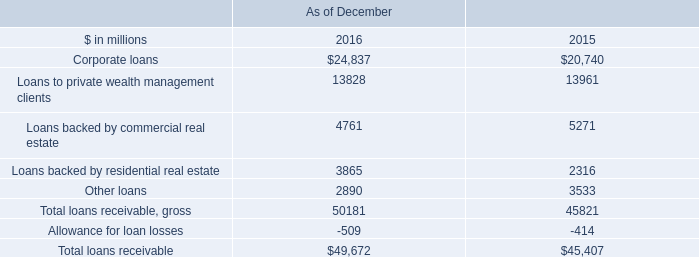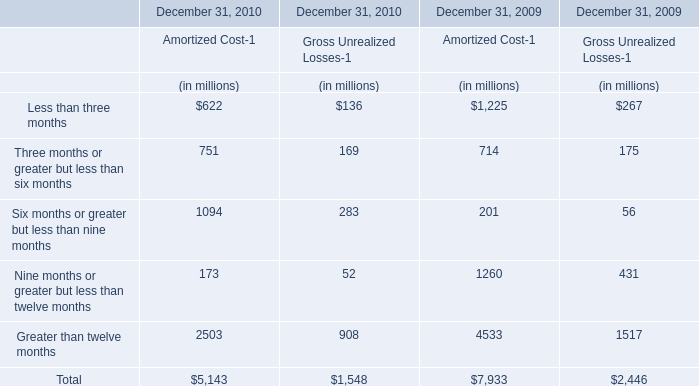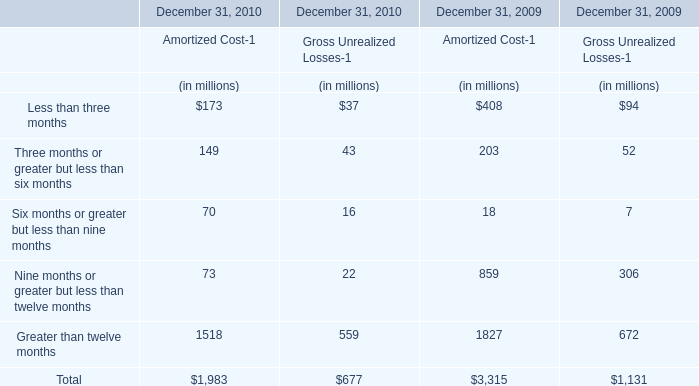What's the growth rate of the Gross Unrealized Losses for Six months or greater but less than nine months on December 31 in 2010? 
Computations: ((283 - 56) / 56)
Answer: 4.05357. 